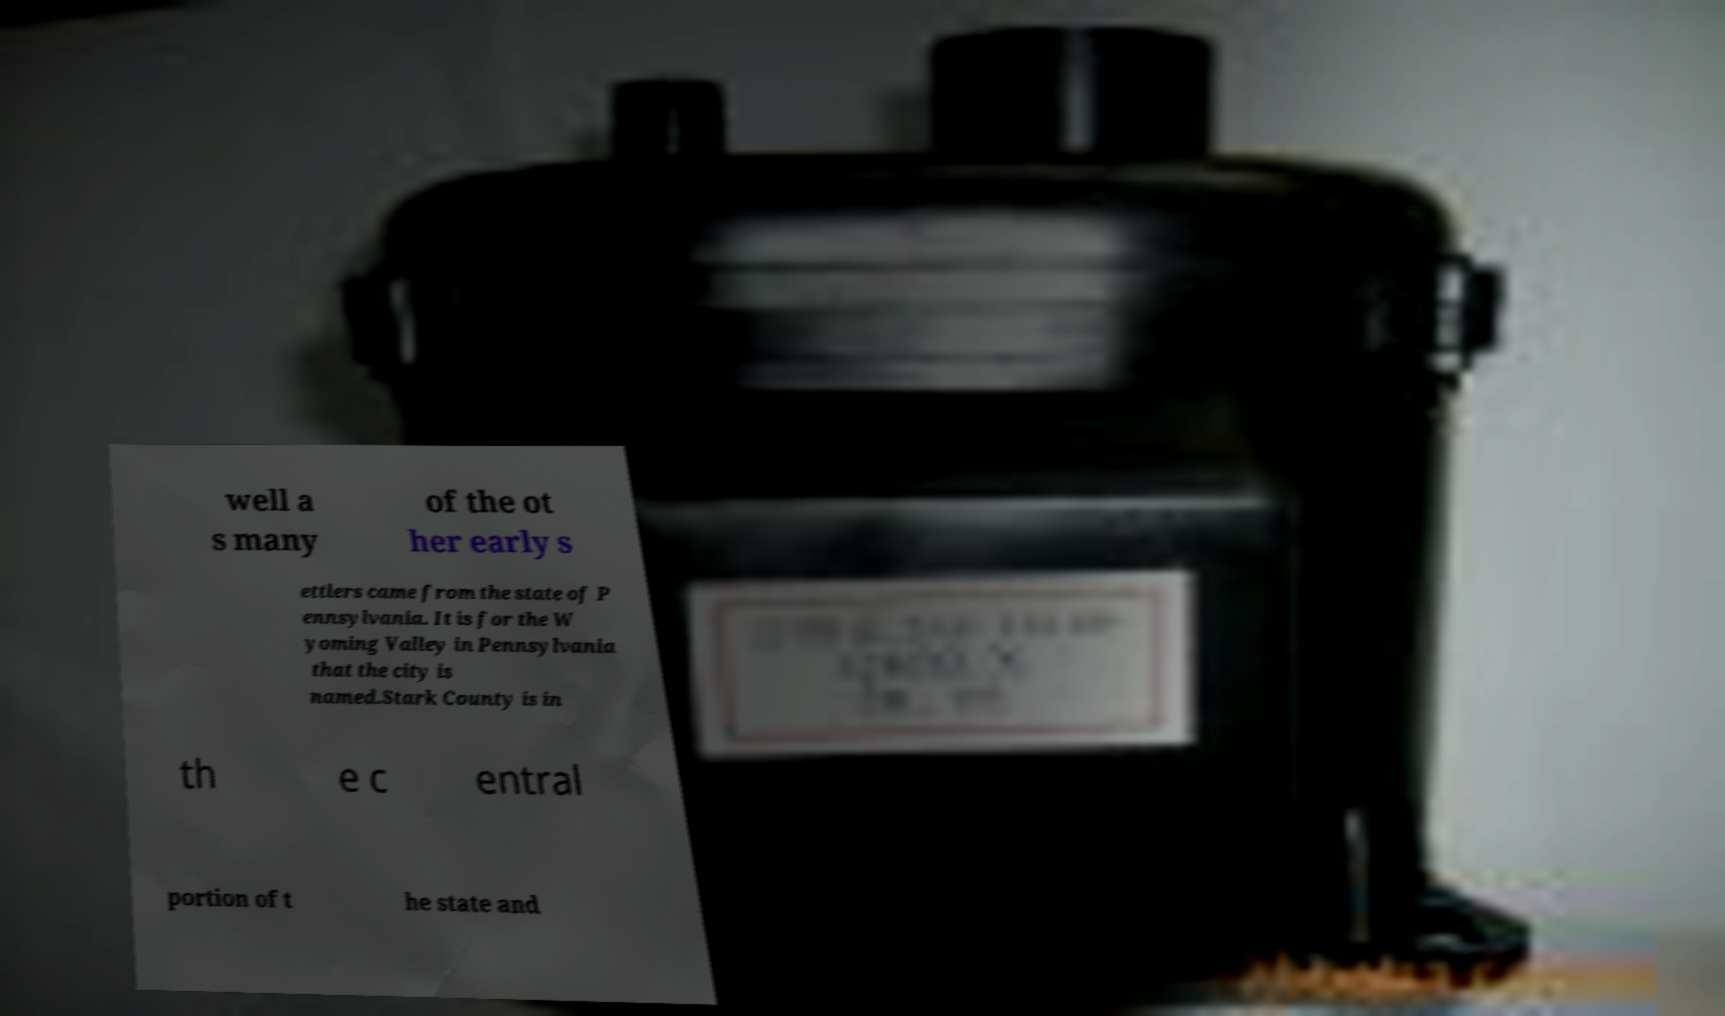Can you read and provide the text displayed in the image?This photo seems to have some interesting text. Can you extract and type it out for me? well a s many of the ot her early s ettlers came from the state of P ennsylvania. It is for the W yoming Valley in Pennsylvania that the city is named.Stark County is in th e c entral portion of t he state and 